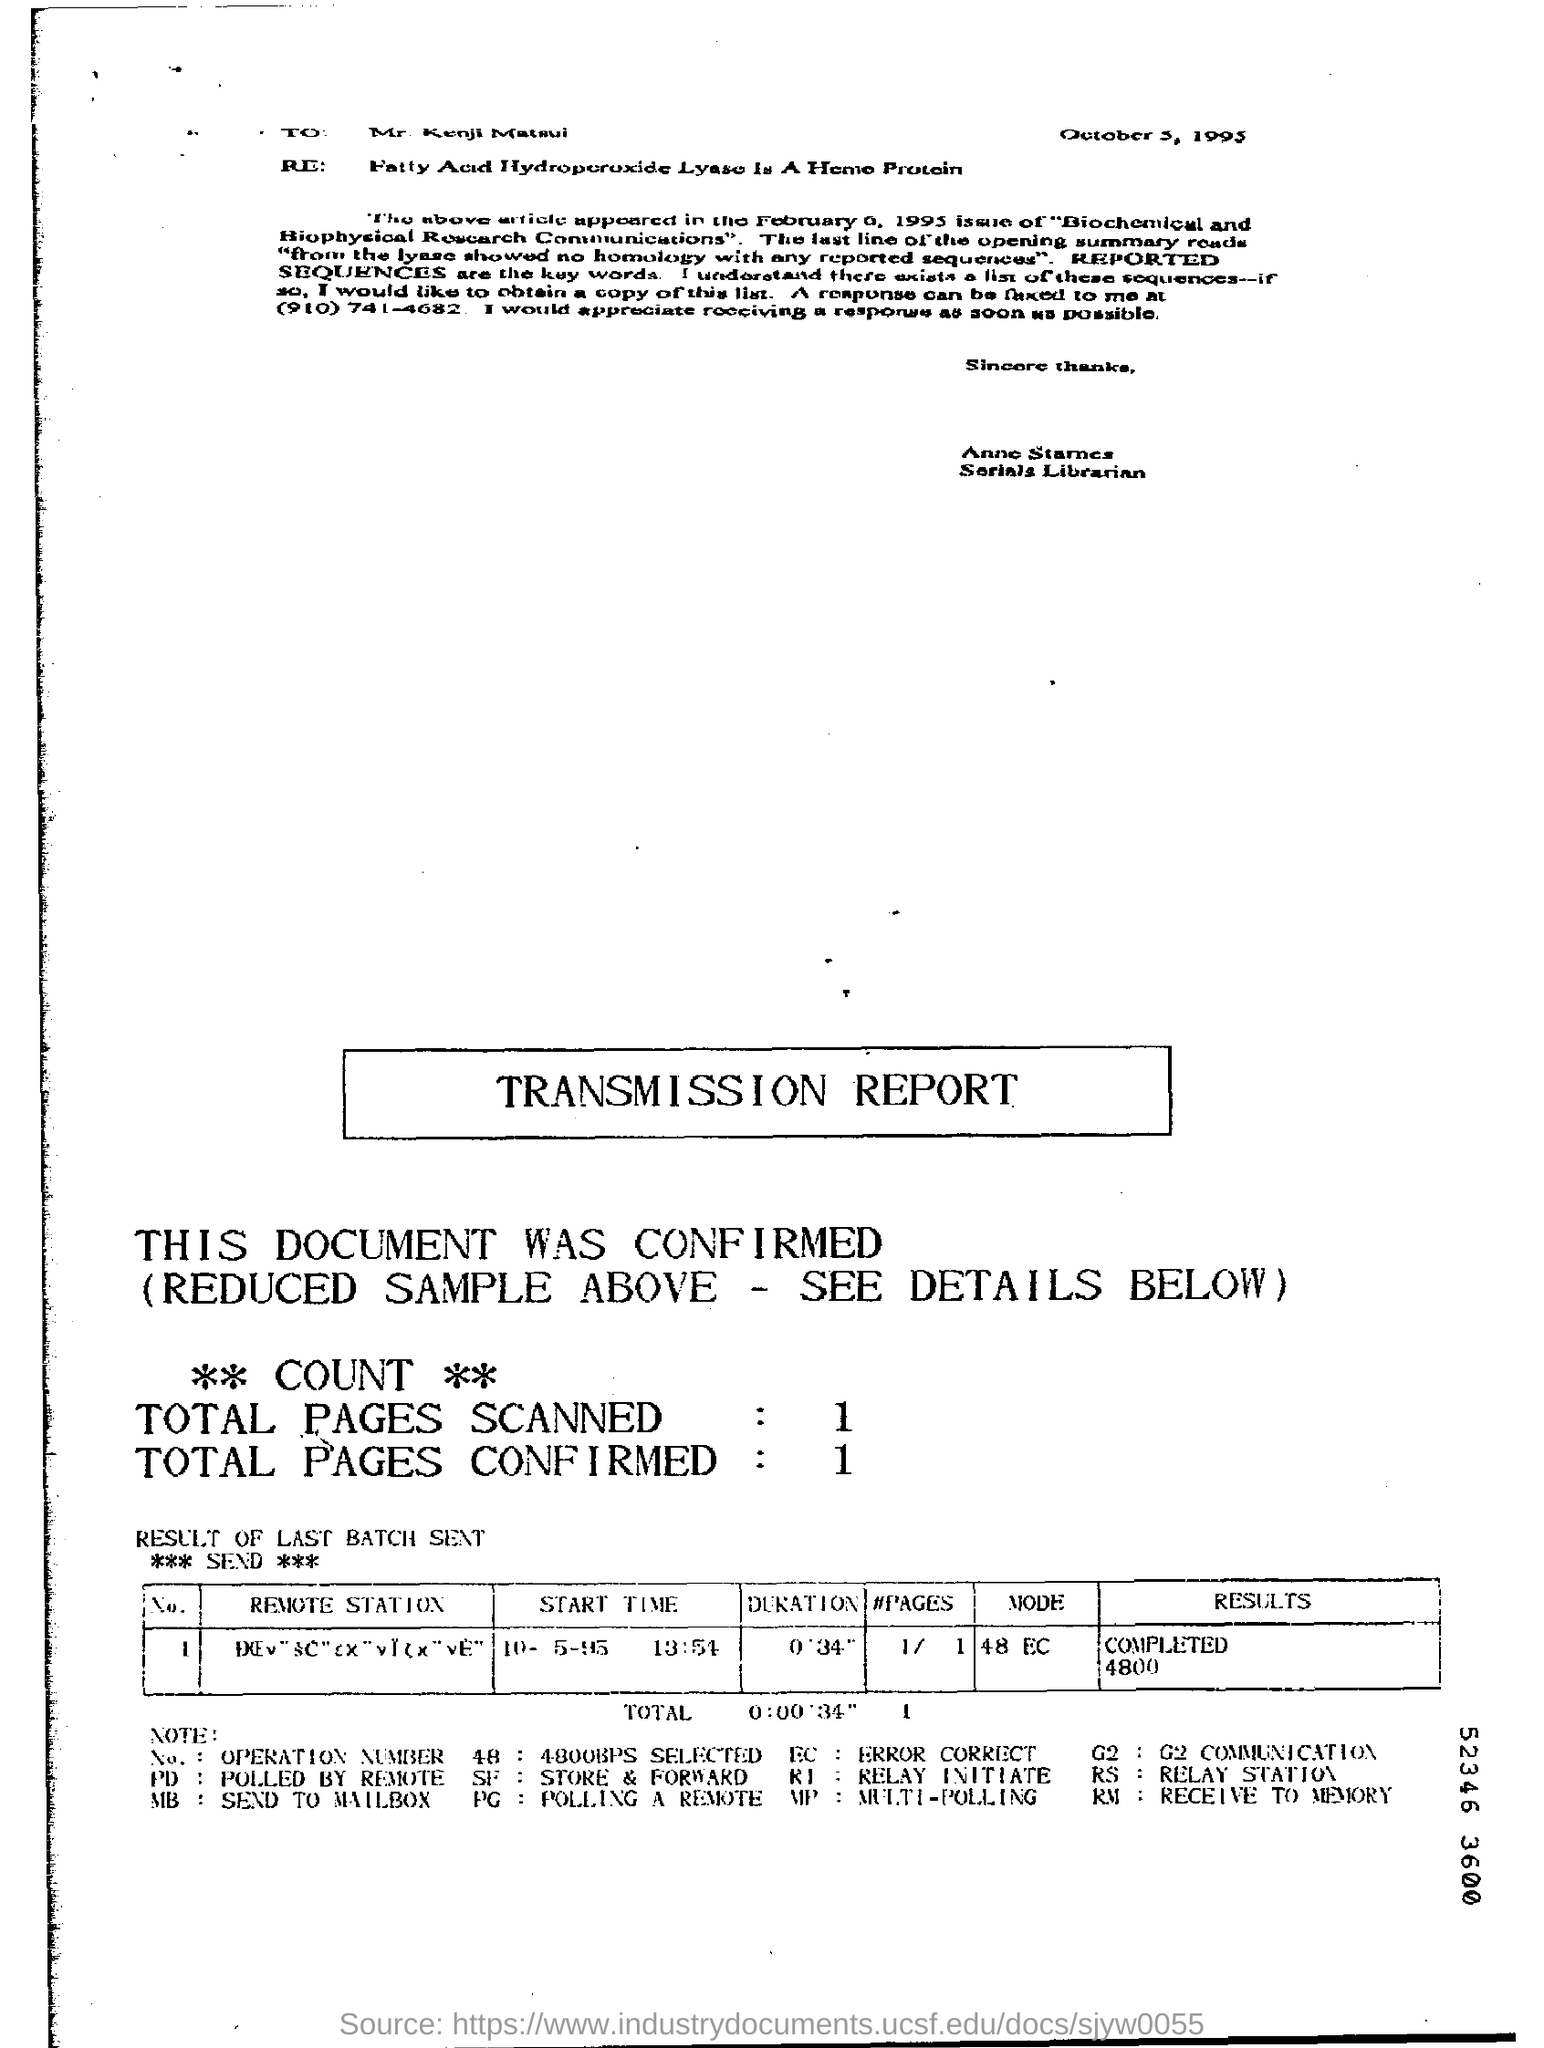Outline some significant characteristics in this image. The letter was written on October 5, 1995. The total number of pages scanned in the transmission report is 1... According to the report, the time duration mentioned is 0 minutes and 34 seconds. The mode, as stated in the report, is 48 EC. The start time of the last batch was on October 5, 1995 at 1:54 PM. 